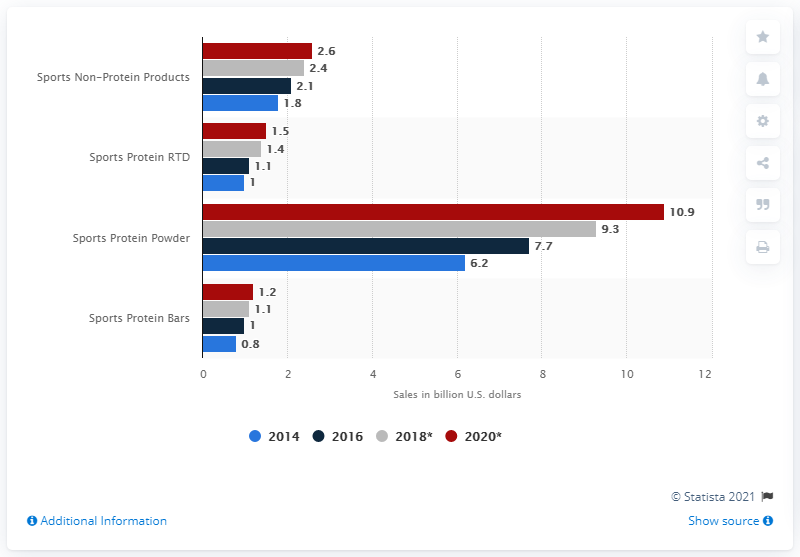Give some essential details in this illustration. Global consumer sports protein powder sales in 2020 are expected to reach approximately 10.9 billion U.S. dollars, according to a credible source. 